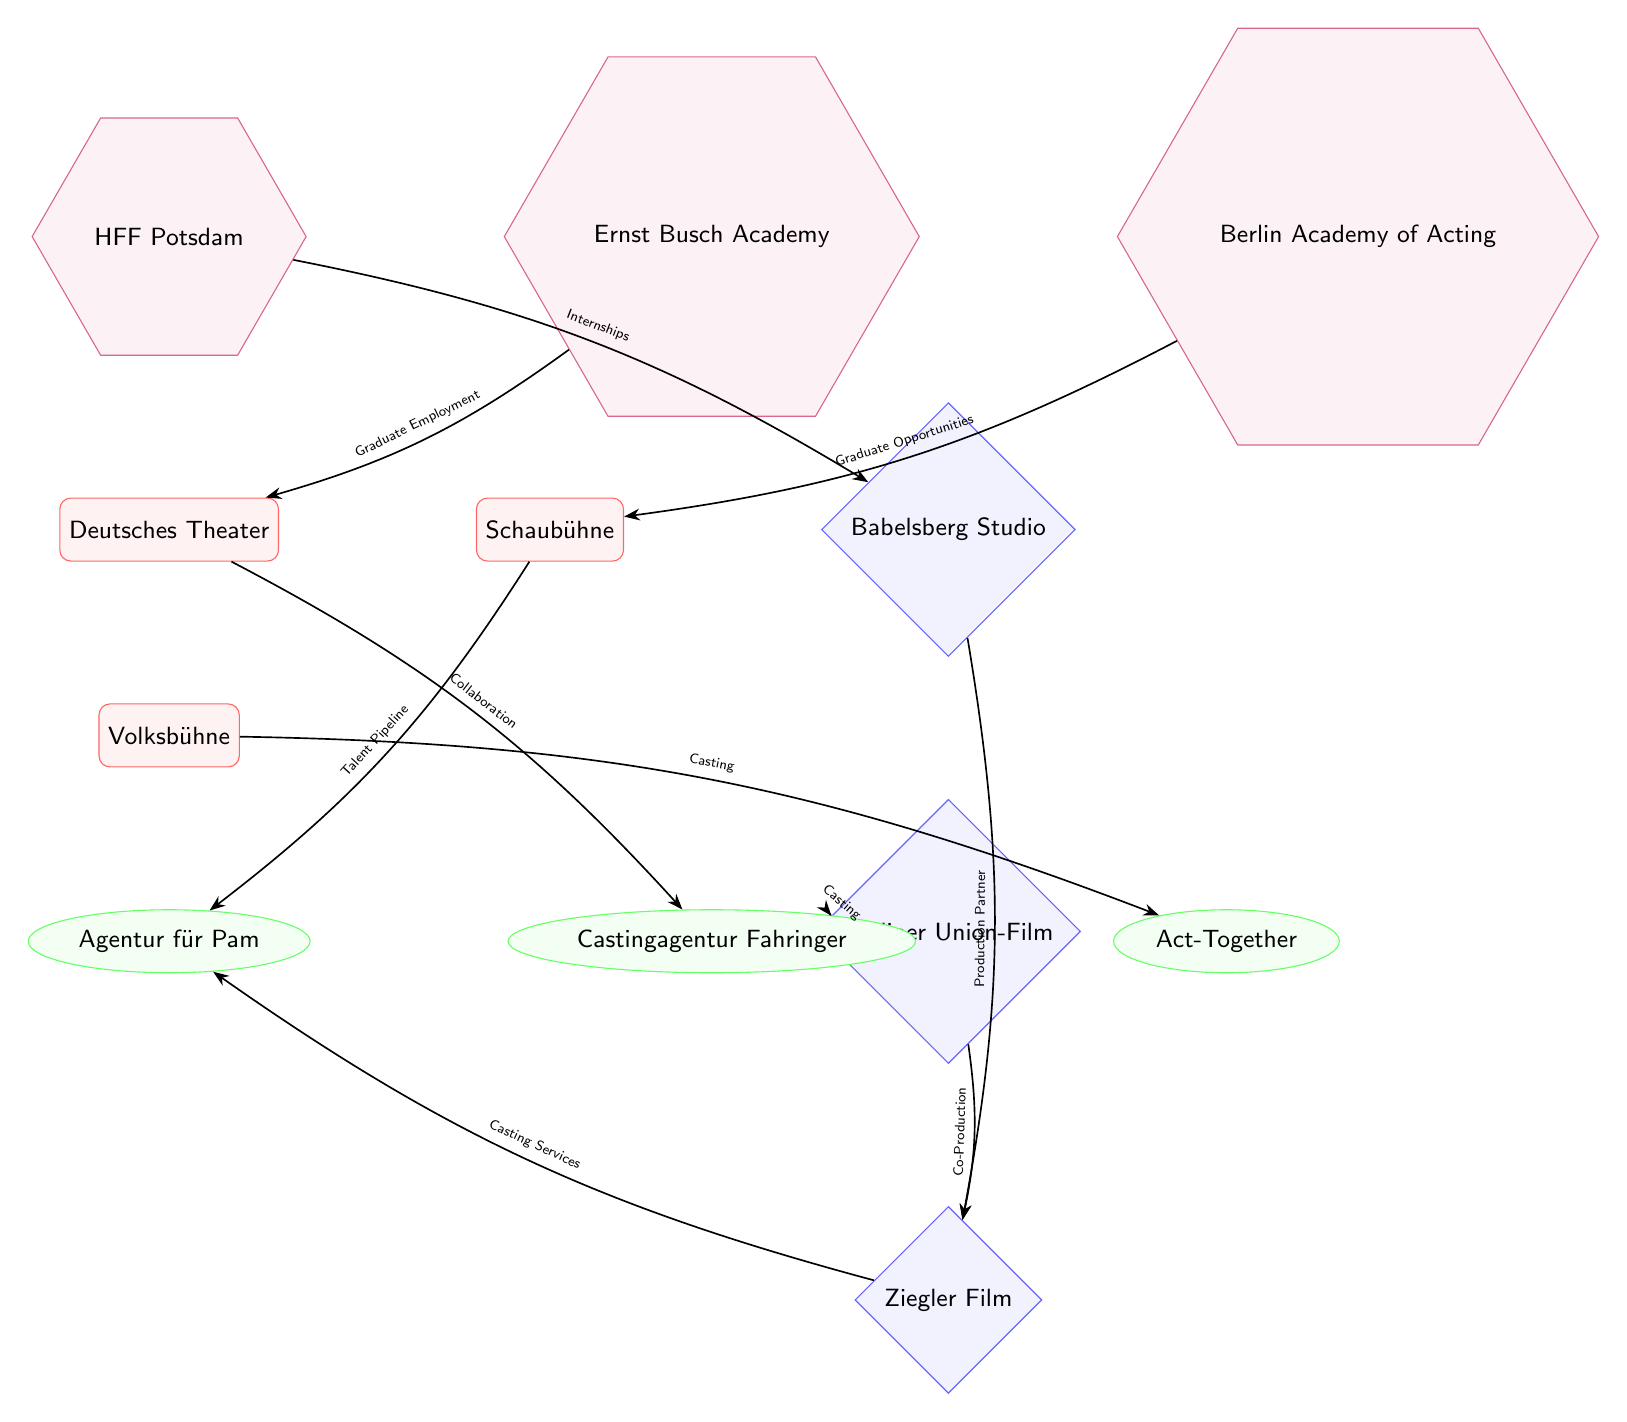What are the three acting schools depicted in the diagram? The diagram shows three acting schools: HFF Potsdam, Ernst Busch Academy, and Berlin Academy of Acting. These can be identified as the regular polygon shapes located above the theaters in the diagram.
Answer: HFF Potsdam, Ernst Busch Academy, Berlin Academy of Acting How many theaters are represented in the diagram? In the diagram, there are three theaters: Deutsches Theater, Schaubühne, and Volksbühne. This can be determined by counting the rectangular nodes labeled as theaters.
Answer: 3 What type of edge connects Volksbühne and Act-Together? The edge between Volksbühne and Act-Together is labeled "Casting," indicating the type of relationship or interaction between these two nodes. This can be read directly from the edge labeling in the diagram.
Answer: Casting Which studio has a co-production relationship with Ziegler Film? Berliner Union-Film has a co-production relationship with Ziegler Film, as indicated by the edge labeled "Co-Production" that connects them in the diagram.
Answer: Berliner Union-Film Which theater facilitates graduate employment? The Deutsches Theater facilitates graduate employment, as shown by the edge connecting it to the Ernst Busch Academy, which is labeled "Graduate Employment."
Answer: Deutsches Theater What key function does the HFF Potsdam serve in relation to Babelsberg Studio? The HFF Potsdam serves the function of providing internships to Babelsberg Studio, as indicated by the edge labeled "Internships" that connects these two nodes in the diagram.
Answer: Internships How many casting agencies are featured in the diagram? There are three casting agencies featured in the diagram: Agentur für Pam, Castingagentur Fahringer, and Act-Together. This is found by counting the elliptical nodes labeled as agencies.
Answer: 3 What is the relationship between Babelsberg Studio and Ziegler Film? The relationship between Babelsberg Studio and Ziegler Film is labeled "Production Partner." This can be confirmed by looking at the edge connecting these two studio nodes in the diagram.
Answer: Production Partner Which theater has a collaboration with Castingagentur Fahringer? The Deutsches Theater has a collaboration with Castingagentur Fahringer, as indicated by the edge linking the two with the label "Collaboration."
Answer: Deutsches Theater 